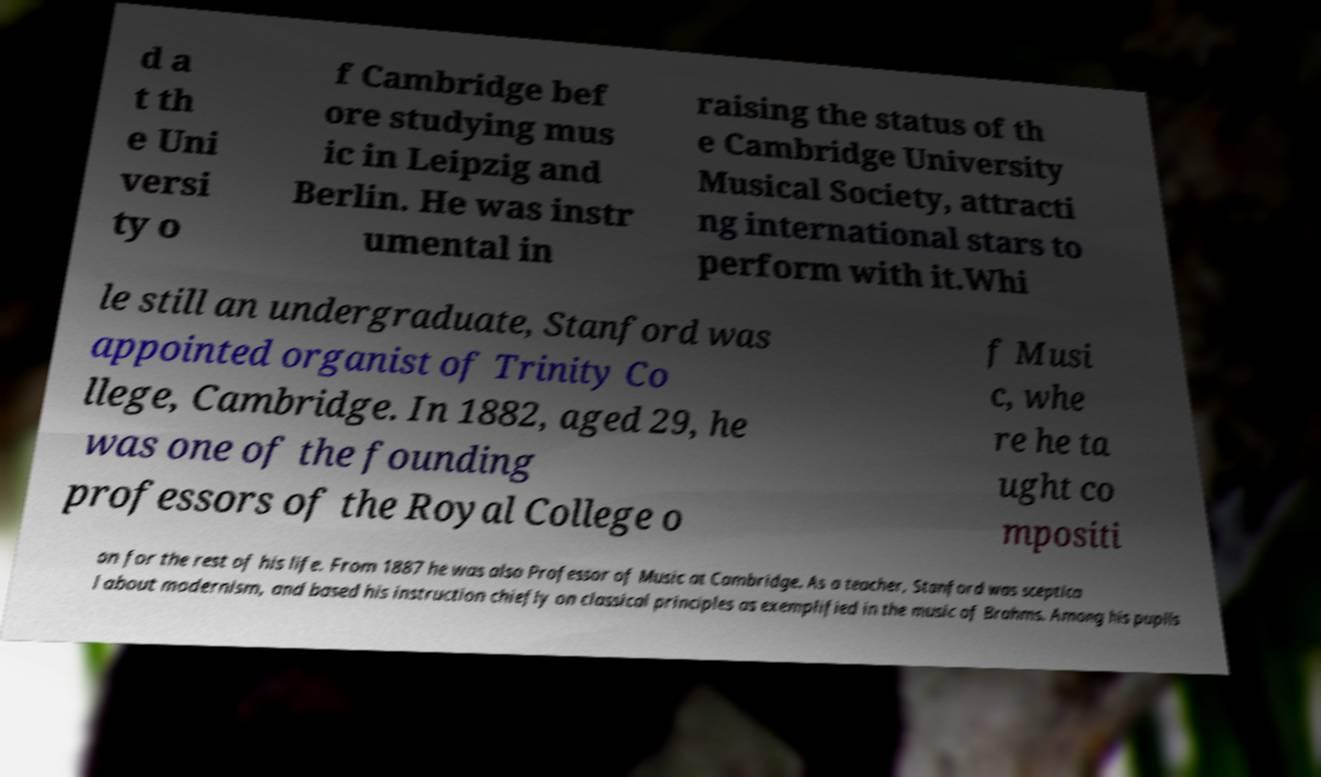What messages or text are displayed in this image? I need them in a readable, typed format. d a t th e Uni versi ty o f Cambridge bef ore studying mus ic in Leipzig and Berlin. He was instr umental in raising the status of th e Cambridge University Musical Society, attracti ng international stars to perform with it.Whi le still an undergraduate, Stanford was appointed organist of Trinity Co llege, Cambridge. In 1882, aged 29, he was one of the founding professors of the Royal College o f Musi c, whe re he ta ught co mpositi on for the rest of his life. From 1887 he was also Professor of Music at Cambridge. As a teacher, Stanford was sceptica l about modernism, and based his instruction chiefly on classical principles as exemplified in the music of Brahms. Among his pupils 